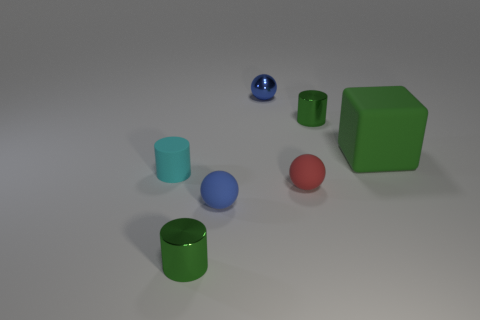What might the different sizes and colors of these objects represent if this were an abstract art piece? If we interpret this as an abstract art piece, the varying sizes could represent the diversity of elements in a system, and the distinct colors might symbolize unique qualities or emotions. The red could stand for passion or urgency, while the calm blue might represent tranquility. The green cylinders could symbolize growth or stability, especially as they stand upright. The spatial arrangement invites contemplation about the interplay between these elements. 